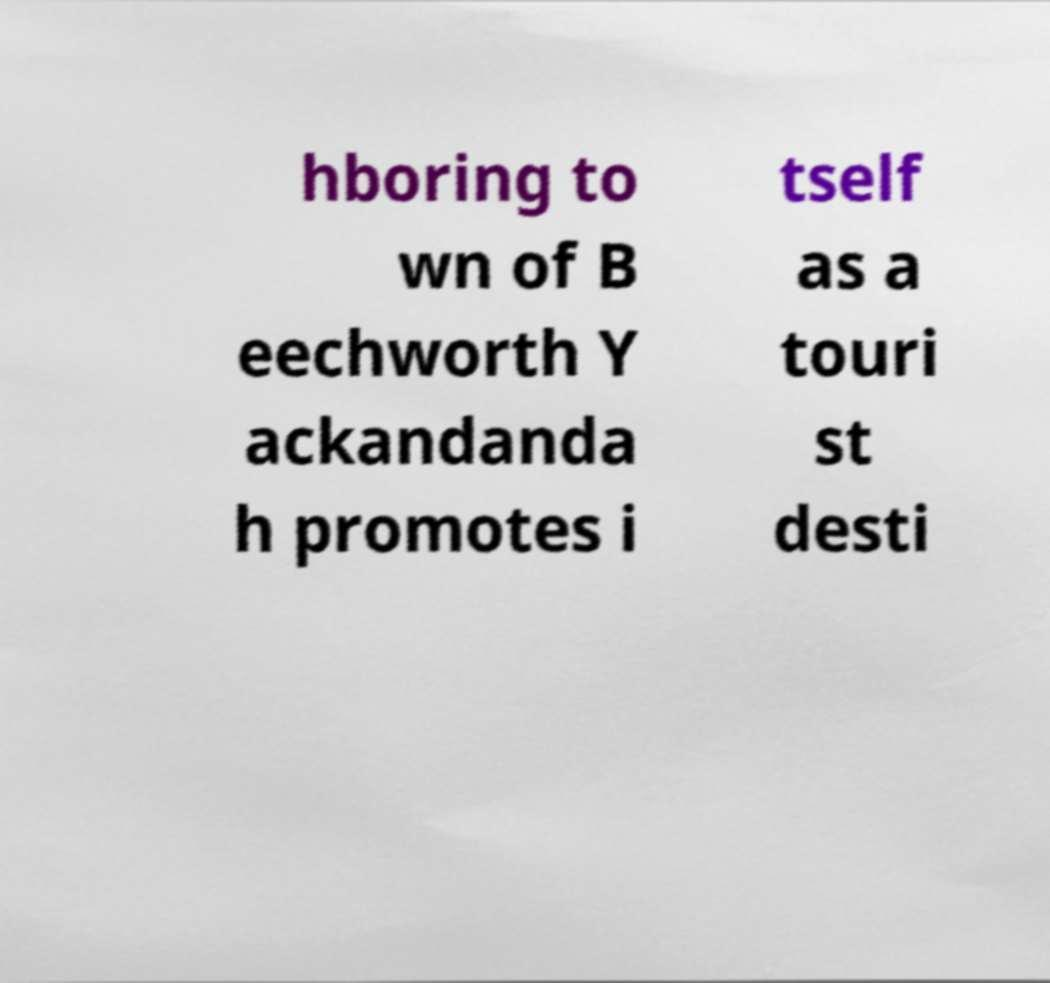Please read and relay the text visible in this image. What does it say? hboring to wn of B eechworth Y ackandanda h promotes i tself as a touri st desti 